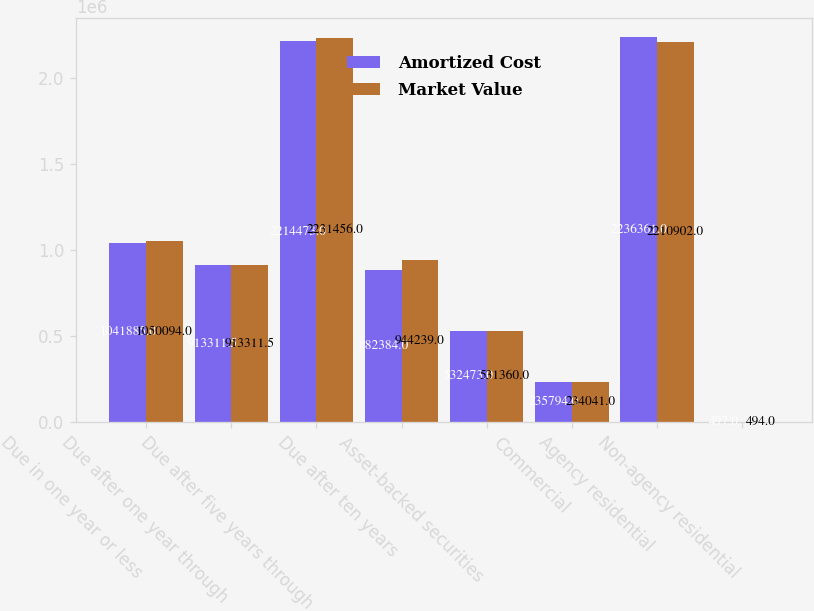<chart> <loc_0><loc_0><loc_500><loc_500><stacked_bar_chart><ecel><fcel>Due in one year or less<fcel>Due after one year through<fcel>Due after five years through<fcel>Due after ten years<fcel>Asset-backed securities<fcel>Commercial<fcel>Agency residential<fcel>Non-agency residential<nl><fcel>Amortized Cost<fcel>1.04188e+06<fcel>913312<fcel>2.21447e+06<fcel>882384<fcel>532473<fcel>235794<fcel>2.23636e+06<fcel>497<nl><fcel>Market Value<fcel>1.05009e+06<fcel>913312<fcel>2.23146e+06<fcel>944239<fcel>531360<fcel>234041<fcel>2.2109e+06<fcel>494<nl></chart> 